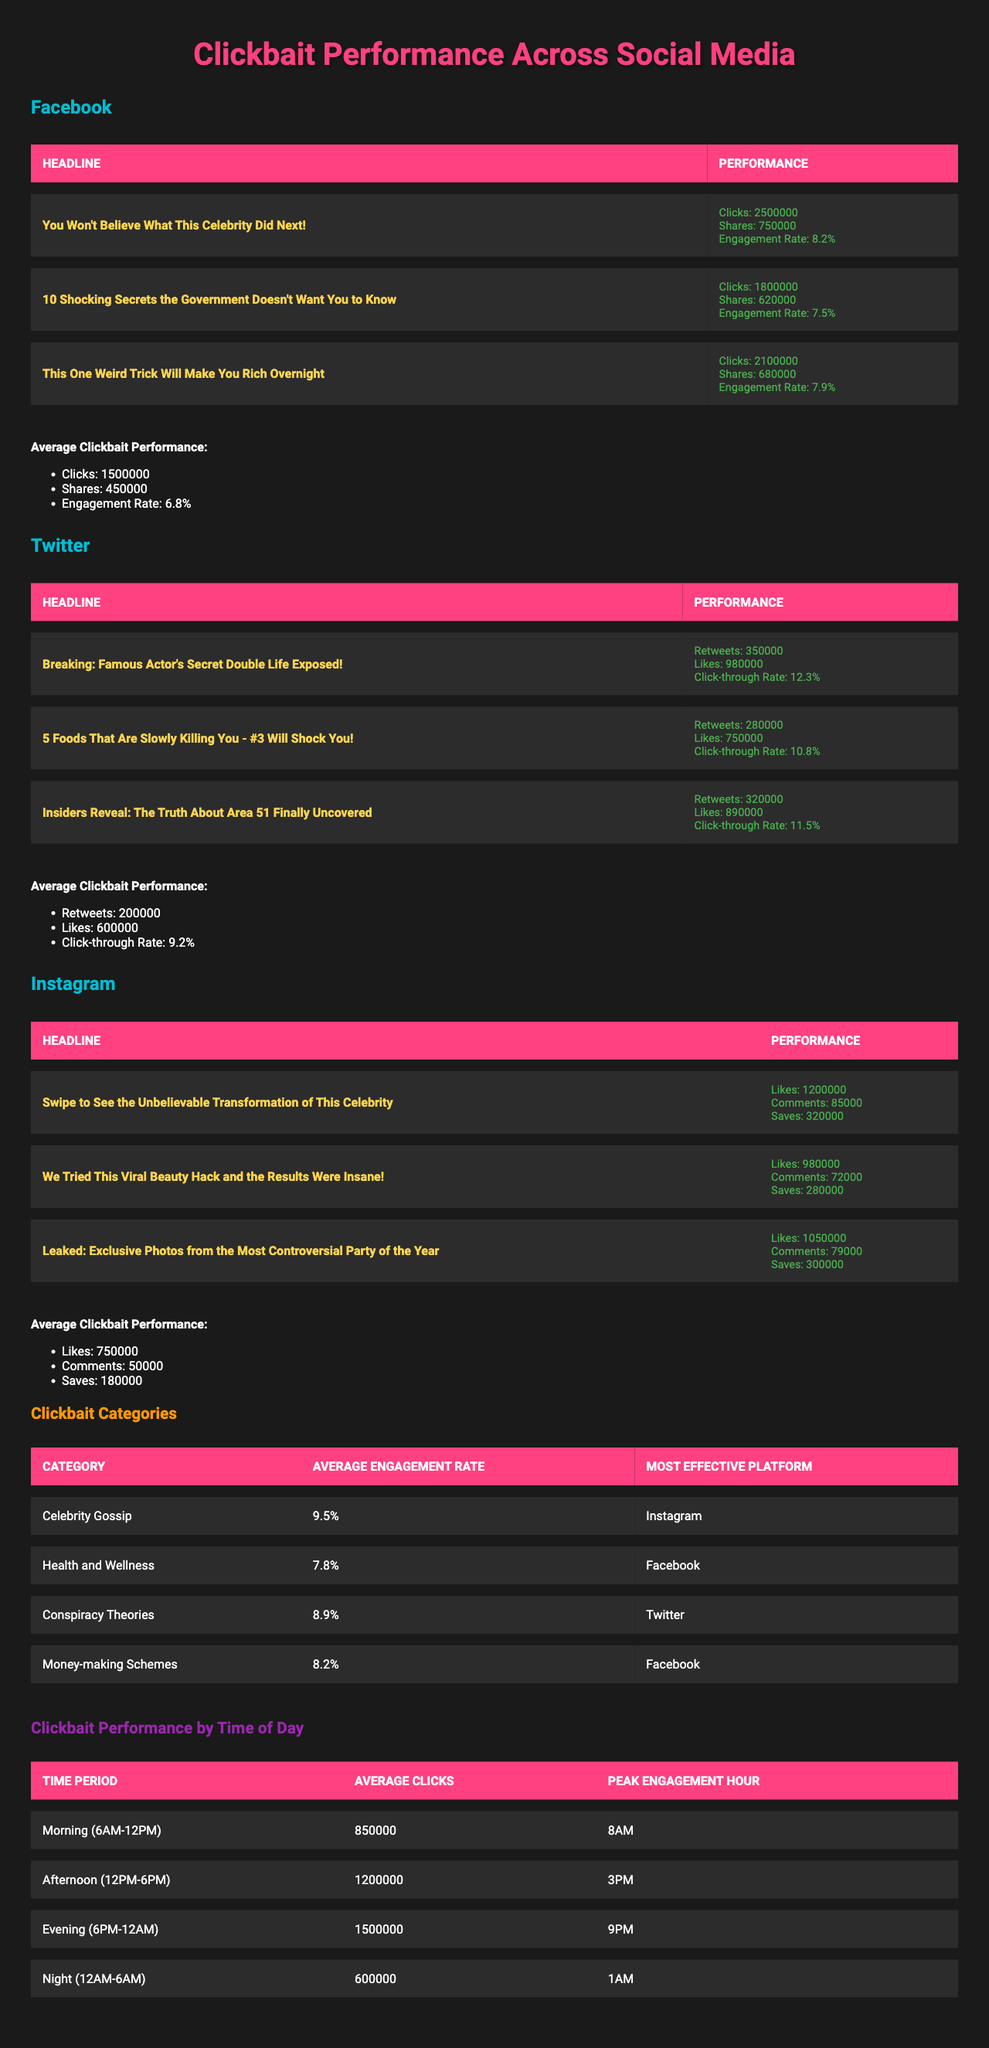What's the total number of clicks on the top performing clickbait headline for Facebook? The top performing clickbait headline for Facebook is "You Won't Believe What This Celebrity Did Next!" with 2,500,000 clicks.
Answer: 2,500,000 Which social media platform has the highest average engagement rate for clickbait categories? The category with the highest average engagement rate is "Celebrity Gossip" at 9.5%, and the most effective platform for that category is Instagram.
Answer: Instagram How many shares did the second top performing clickbait headline on Facebook receive? The second top performing headline is "10 Shocking Secrets the Government Doesn't Want You to Know," which received 620,000 shares.
Answer: 620,000 What is the average click-through rate for Twitter? The average click-through rate for Twitter is 9.2%, as noted in its average clickbait performance section.
Answer: 9.2% Which clickbait category has the lowest average engagement rate? The "Health and Wellness" category has the lowest average engagement rate at 7.8%.
Answer: 7.8% Compare the total clicks for Instagram's top performing headlines. What is the difference between the highest and lowest clicks? The highest performing headline on Instagram has 1,200,000 likes and the lowest has 980,000. The difference is 1,200,000 - 980,000 = 220,000.
Answer: 220,000 Which time of day shows the peak engagement hour for average clicks? The evening (6PM-12AM) has the peak engagement hour at 9PM, with an average of 1,500,000 clicks.
Answer: 9PM How many likes did the clickbait headline that received the most engagement on Instagram acquire? The clickbait headline "Swipe to See the Unbelievable Transformation of This Celebrity" received 1,200,000 likes, making it the one with the most engagement.
Answer: 1,200,000 Is the average number of likes on Instagram higher than the average number of shares on Facebook? Yes, the average number of likes on Instagram is 750,000, which is higher than the average shares on Facebook of 450,000.
Answer: Yes What is the average number of clicks in the morning time period? The average number of clicks in the morning (6AM-12PM) time period is 850,000, as indicated in the summary of clickbait performance by time of day.
Answer: 850,000 